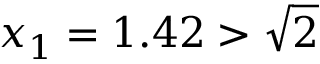Convert formula to latex. <formula><loc_0><loc_0><loc_500><loc_500>x _ { 1 } = 1 . 4 2 > { \sqrt { 2 } }</formula> 